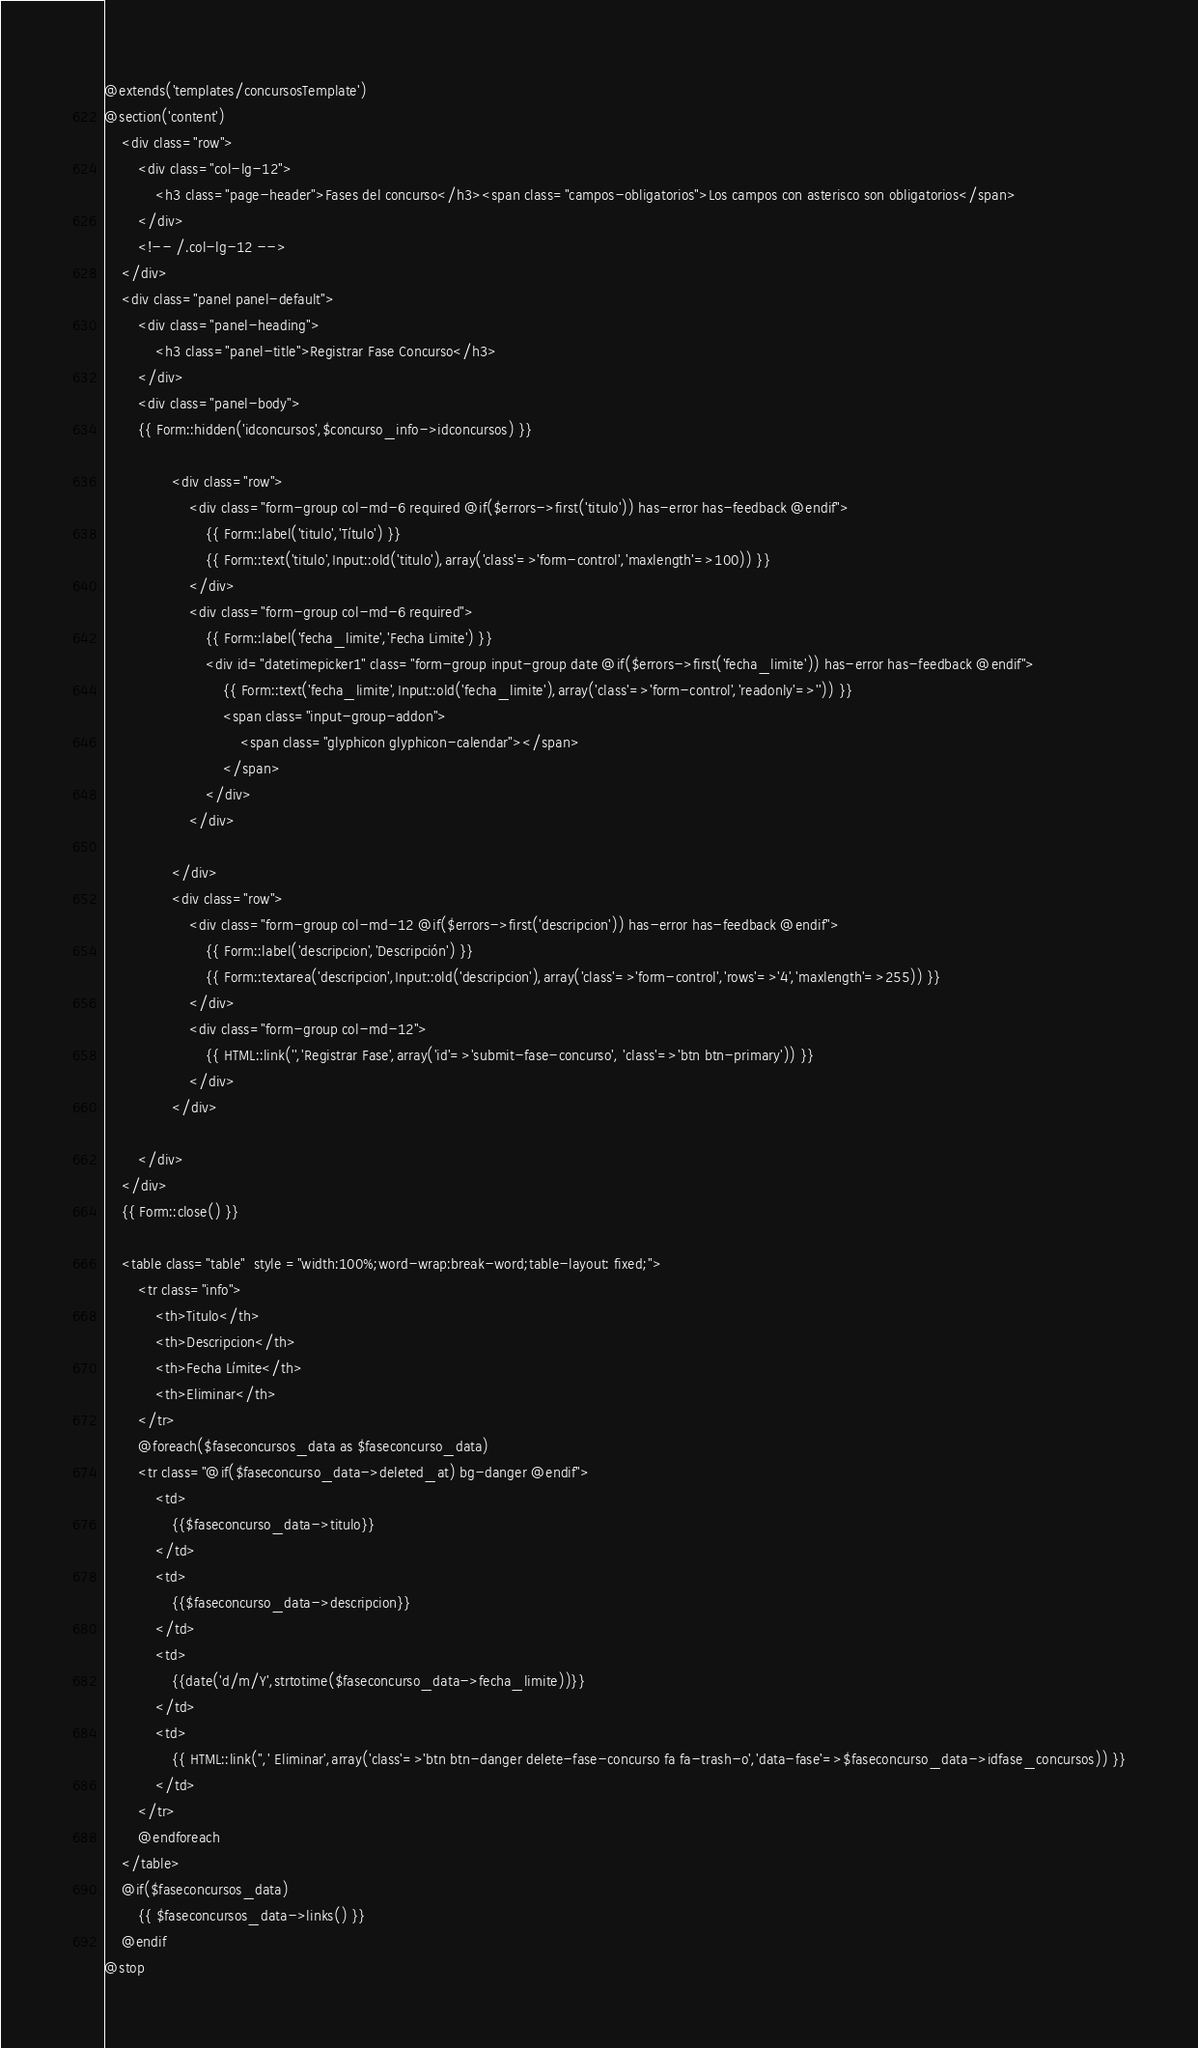<code> <loc_0><loc_0><loc_500><loc_500><_PHP_>@extends('templates/concursosTemplate')	
@section('content')
	<div class="row">
        <div class="col-lg-12">
            <h3 class="page-header">Fases del concurso</h3><span class="campos-obligatorios">Los campos con asterisco son obligatorios</span>
        </div>
        <!-- /.col-lg-12 -->
    </div>
    <div class="panel panel-default">
		<div class="panel-heading">
			<h3 class="panel-title">Registrar Fase Concurso</h3>
		</div>
		<div class="panel-body">
	    {{ Form::hidden('idconcursos',$concurso_info->idconcursos) }}
		
				<div class="row">
					<div class="form-group col-md-6 required @if($errors->first('titulo')) has-error has-feedback @endif">
						{{ Form::label('titulo','Título') }}
						{{ Form::text('titulo',Input::old('titulo'),array('class'=>'form-control','maxlength'=>100)) }}
					</div>
					<div class="form-group col-md-6 required">
						{{ Form::label('fecha_limite','Fecha Limite') }}
						<div id="datetimepicker1" class="form-group input-group date @if($errors->first('fecha_limite')) has-error has-feedback @endif">
							{{ Form::text('fecha_limite',Input::old('fecha_limite'),array('class'=>'form-control','readonly'=>'')) }}
							<span class="input-group-addon">
			                    <span class="glyphicon glyphicon-calendar"></span>
			                </span>
						</div>
					</div>
				
				</div>
				<div class="row">
					<div class="form-group col-md-12 @if($errors->first('descripcion')) has-error has-feedback @endif">
						{{ Form::label('descripcion','Descripción') }}
						{{ Form::textarea('descripcion',Input::old('descripcion'),array('class'=>'form-control','rows'=>'4','maxlength'=>255)) }}
					</div>
					<div class="form-group col-md-12">
						{{ HTML::link('','Registrar Fase',array('id'=>'submit-fase-concurso', 'class'=>'btn btn-primary')) }}	
					</div>
				</div>
		
		</div>
	</div>
	{{ Form::close() }}  

	<table class="table"  style ="width:100%;word-wrap:break-word;table-layout: fixed;">
		<tr class="info">
			<th>Titulo</th>
			<th>Descripcion</th>
			<th>Fecha Límite</th>
			<th>Eliminar</th>
		</tr>
		@foreach($faseconcursos_data as $faseconcurso_data)
		<tr class="@if($faseconcurso_data->deleted_at) bg-danger @endif">				
			<td>
				{{$faseconcurso_data->titulo}}
			</td>
			<td>
				{{$faseconcurso_data->descripcion}}
			</td>
			<td>
				{{date('d/m/Y',strtotime($faseconcurso_data->fecha_limite))}}
			</td>			
			<td>
				{{ HTML::link('',' Eliminar',array('class'=>'btn btn-danger delete-fase-concurso fa fa-trash-o','data-fase'=>$faseconcurso_data->idfase_concursos)) }}
			</td>
		</tr>
		@endforeach
	</table>
	@if($faseconcursos_data)
		{{ $faseconcursos_data->links() }}
	@endif
@stop</code> 